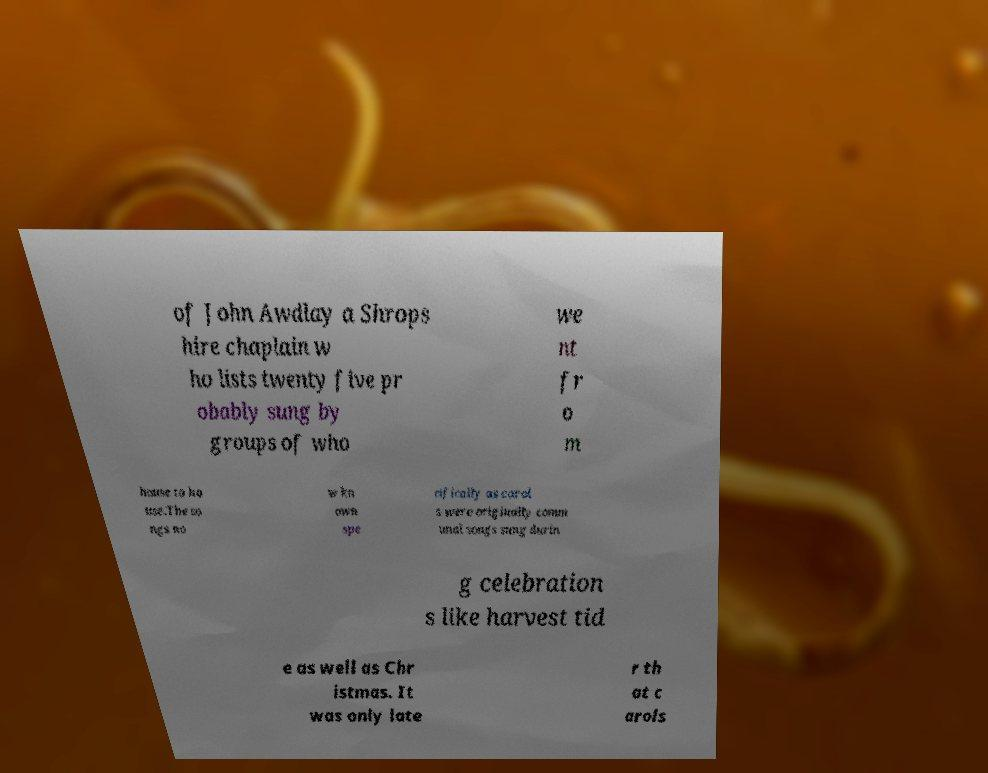Please identify and transcribe the text found in this image. of John Awdlay a Shrops hire chaplain w ho lists twenty five pr obably sung by groups of who we nt fr o m house to ho use.The so ngs no w kn own spe cifically as carol s were originally comm unal songs sung durin g celebration s like harvest tid e as well as Chr istmas. It was only late r th at c arols 